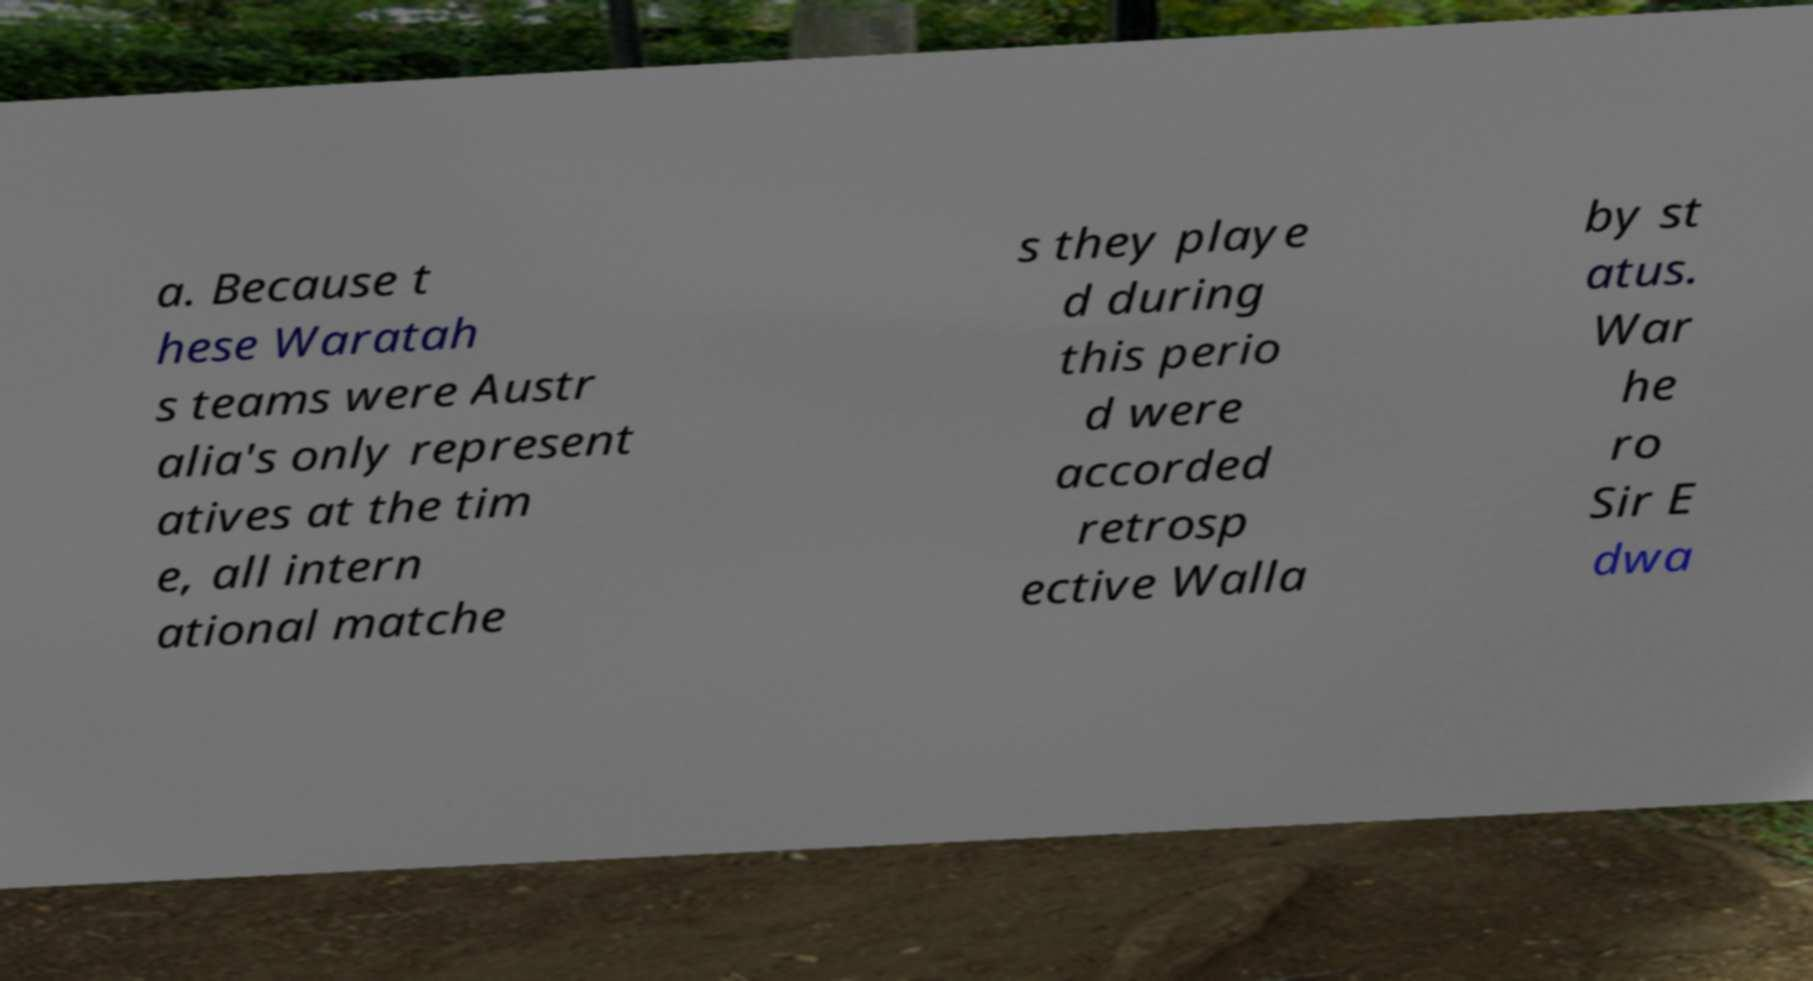Could you assist in decoding the text presented in this image and type it out clearly? a. Because t hese Waratah s teams were Austr alia's only represent atives at the tim e, all intern ational matche s they playe d during this perio d were accorded retrosp ective Walla by st atus. War he ro Sir E dwa 